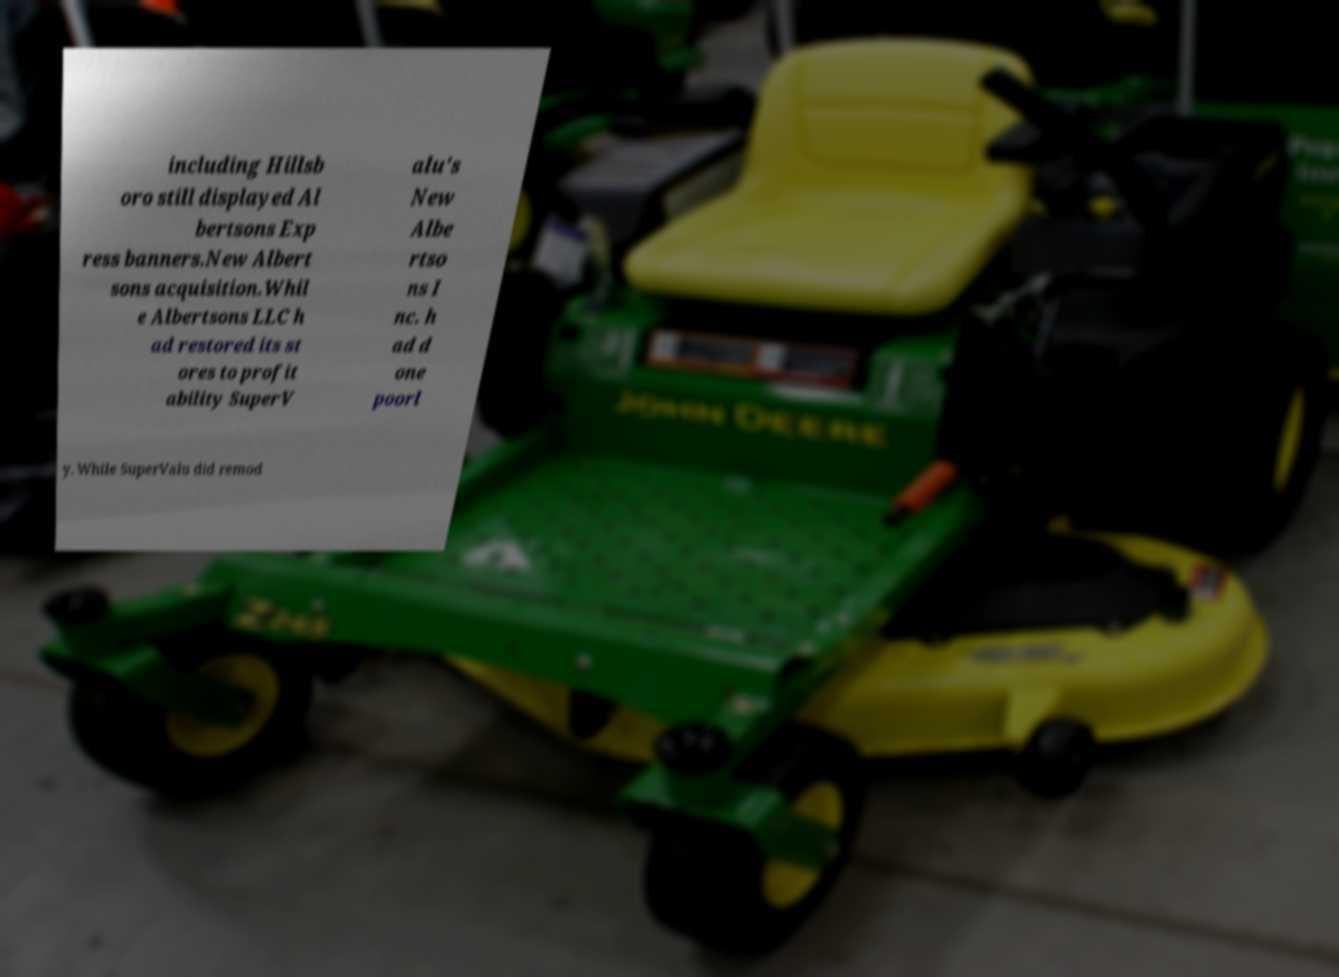Please read and relay the text visible in this image. What does it say? including Hillsb oro still displayed Al bertsons Exp ress banners.New Albert sons acquisition.Whil e Albertsons LLC h ad restored its st ores to profit ability SuperV alu's New Albe rtso ns I nc. h ad d one poorl y. While SuperValu did remod 